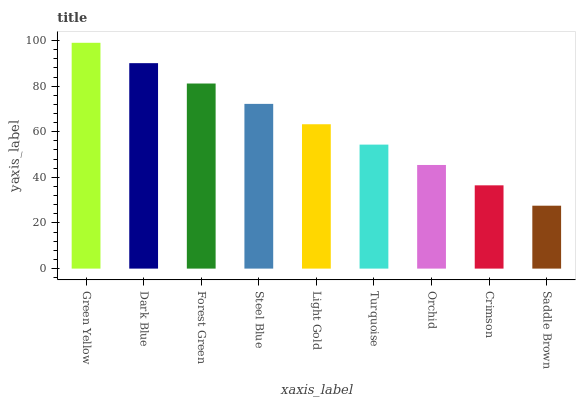Is Dark Blue the minimum?
Answer yes or no. No. Is Dark Blue the maximum?
Answer yes or no. No. Is Green Yellow greater than Dark Blue?
Answer yes or no. Yes. Is Dark Blue less than Green Yellow?
Answer yes or no. Yes. Is Dark Blue greater than Green Yellow?
Answer yes or no. No. Is Green Yellow less than Dark Blue?
Answer yes or no. No. Is Light Gold the high median?
Answer yes or no. Yes. Is Light Gold the low median?
Answer yes or no. Yes. Is Green Yellow the high median?
Answer yes or no. No. Is Crimson the low median?
Answer yes or no. No. 